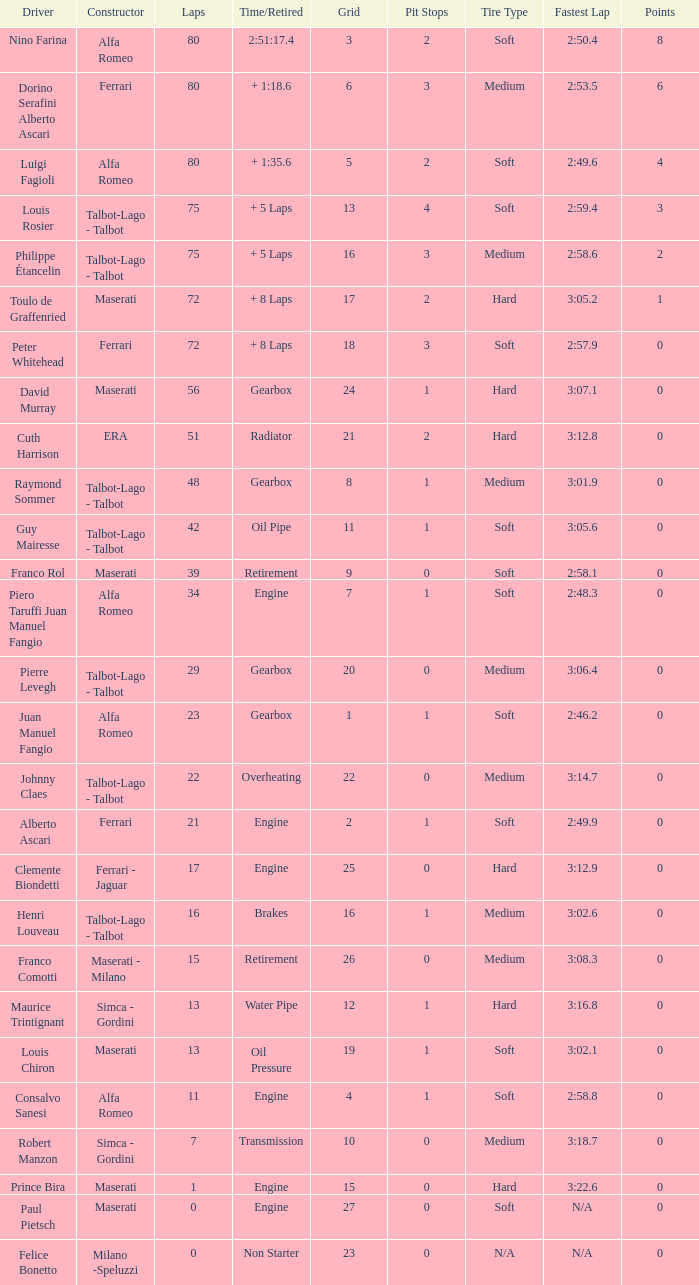What was the smallest grid for Prince bira? 15.0. 